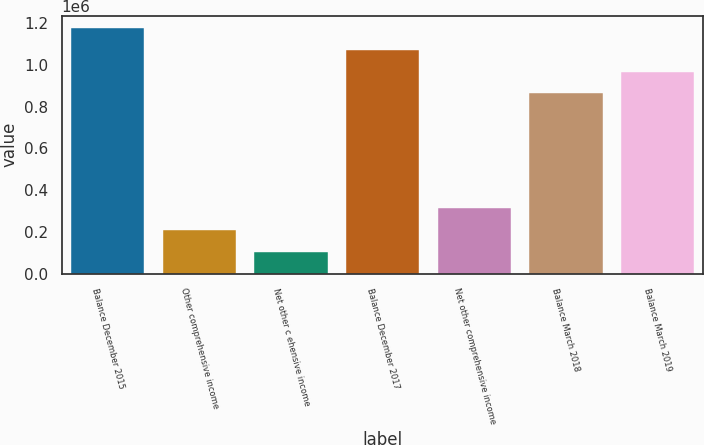<chart> <loc_0><loc_0><loc_500><loc_500><bar_chart><fcel>Balance December 2015<fcel>Other comprehensive income<fcel>Net other c ehensive income<fcel>Balance December 2017<fcel>Net other comprehensive income<fcel>Balance March 2018<fcel>Balance March 2019<nl><fcel>1.17692e+06<fcel>208860<fcel>104564<fcel>1.07262e+06<fcel>313155<fcel>864030<fcel>968325<nl></chart> 